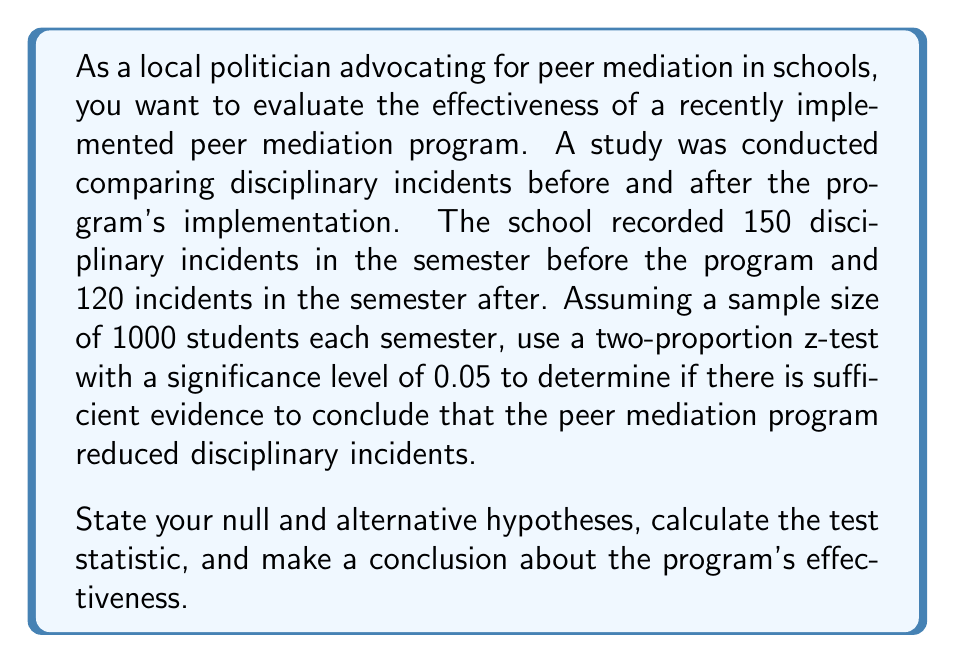Give your solution to this math problem. Let's approach this step-by-step:

1) Define the hypotheses:
   $H_0: p_1 = p_2$ (null hypothesis: no difference in proportions)
   $H_a: p_1 > p_2$ (alternative hypothesis: proportion before is greater than after)

   Where $p_1$ is the proportion of incidents before the program, and $p_2$ is the proportion after.

2) Calculate the sample proportions:
   $\hat{p}_1 = 150/1000 = 0.15$
   $\hat{p}_2 = 120/1000 = 0.12$

3) Calculate the pooled proportion:
   $$\hat{p} = \frac{X_1 + X_2}{n_1 + n_2} = \frac{150 + 120}{1000 + 1000} = \frac{270}{2000} = 0.135$$

4) Calculate the standard error:
   $$SE = \sqrt{\hat{p}(1-\hat{p})(\frac{1}{n_1} + \frac{1}{n_2})}$$
   $$SE = \sqrt{0.135(1-0.135)(\frac{1}{1000} + \frac{1}{1000})} = 0.0153$$

5) Calculate the z-statistic:
   $$z = \frac{\hat{p}_1 - \hat{p}_2}{\sqrt{\hat{p}(1-\hat{p})(\frac{1}{n_1} + \frac{1}{n_2})}}$$
   $$z = \frac{0.15 - 0.12}{0.0153} = 1.96$$

6) Find the critical value:
   For a one-tailed test at α = 0.05, the critical z-value is 1.645.

7) Make a decision:
   Since the calculated z-value (1.96) is greater than the critical value (1.645), we reject the null hypothesis.

8) Conclusion:
   There is sufficient evidence at the 0.05 significance level to conclude that the peer mediation program reduced disciplinary incidents.
Answer: Reject $H_0$. There is sufficient evidence at the 0.05 significance level to conclude that the peer mediation program reduced disciplinary incidents (z = 1.96, p < 0.05). 